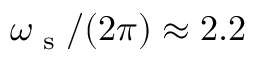<formula> <loc_0><loc_0><loc_500><loc_500>\omega _ { s } / ( 2 \pi ) \approx 2 . 2</formula> 